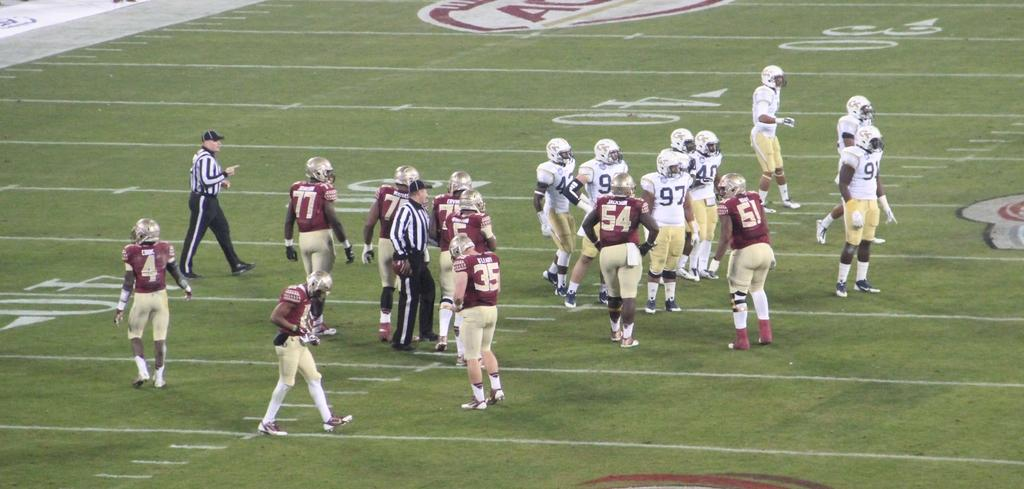What can be seen in the image in terms of human presence? There are groups of people in the image. How are the people positioned in the image? The people are standing. What are the people wearing on their heads? The people are wearing helmets. What type of costumes are the people wearing? The people are wearing American football player costumes. Can you describe the setting of the image? The image appears to depict a ground or similar outdoor area. What type of coal is being used for the ornament in the image? There is no coal or ornament present in the image. What kind of operation is being performed by the people in the image? The image does not depict any operation being performed by the people; they are simply standing in American football player costumes. 